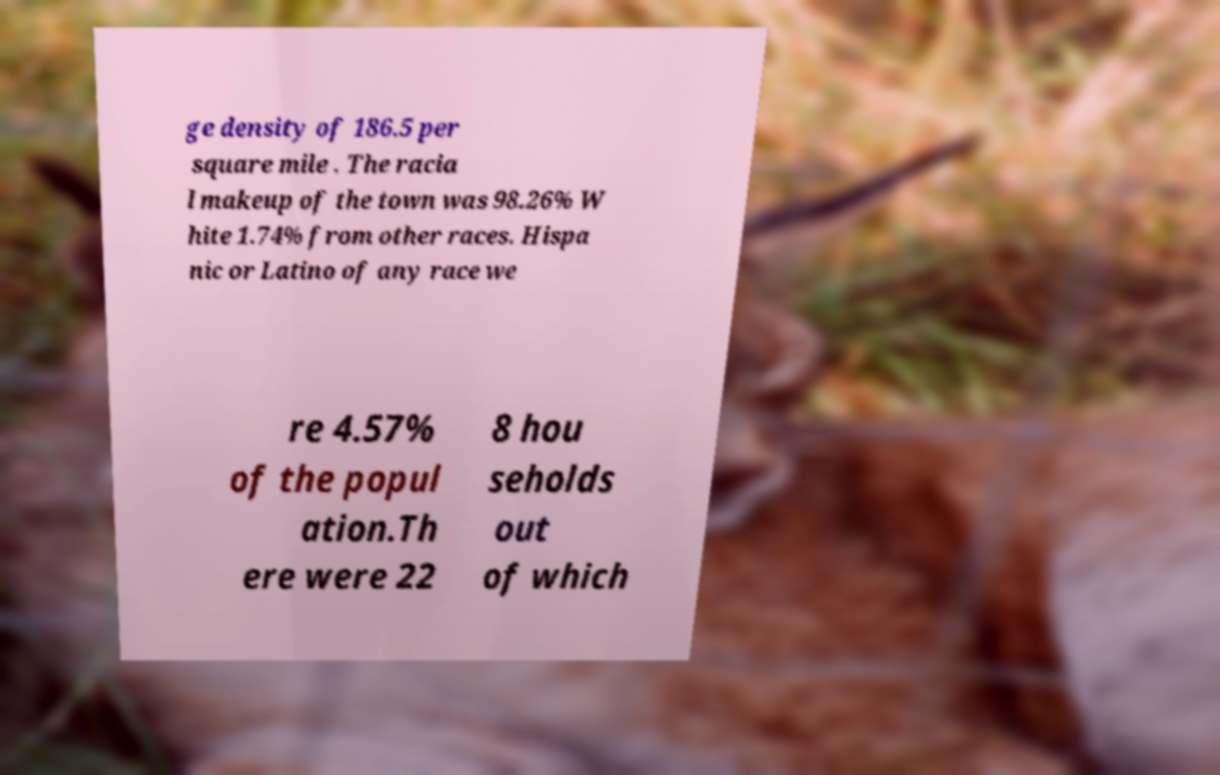I need the written content from this picture converted into text. Can you do that? ge density of 186.5 per square mile . The racia l makeup of the town was 98.26% W hite 1.74% from other races. Hispa nic or Latino of any race we re 4.57% of the popul ation.Th ere were 22 8 hou seholds out of which 